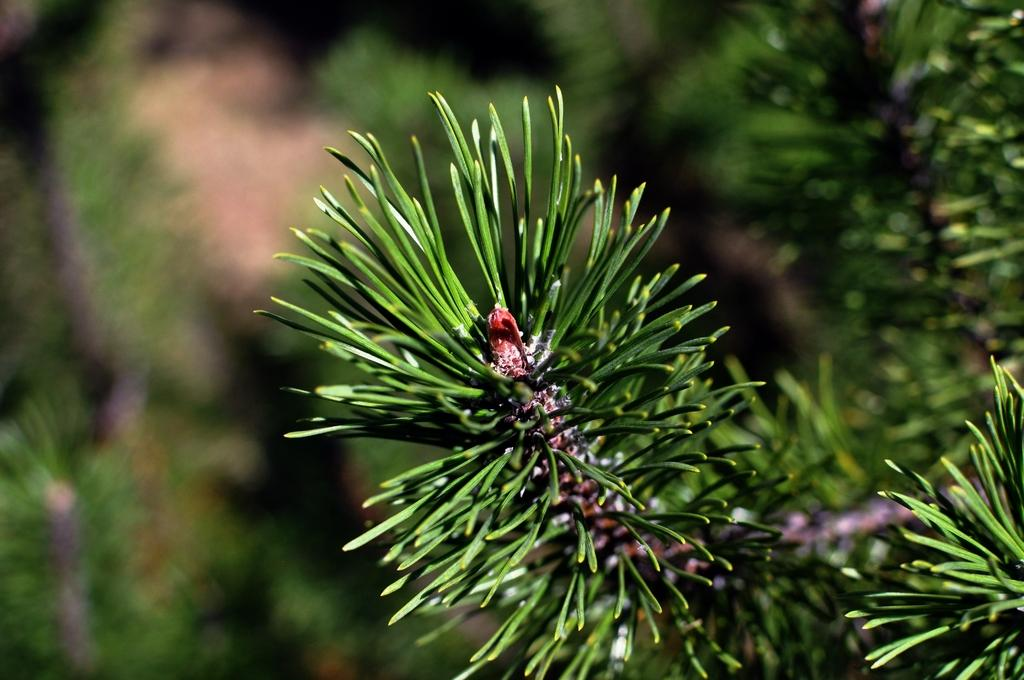What is the main subject in the image? There is a plant in the image. Can you describe the background of the image? The background of the image is blurred. What type of ghost can be seen interacting with the plant in the image? There is no ghost present in the image; it only features a plant and a blurred background. 